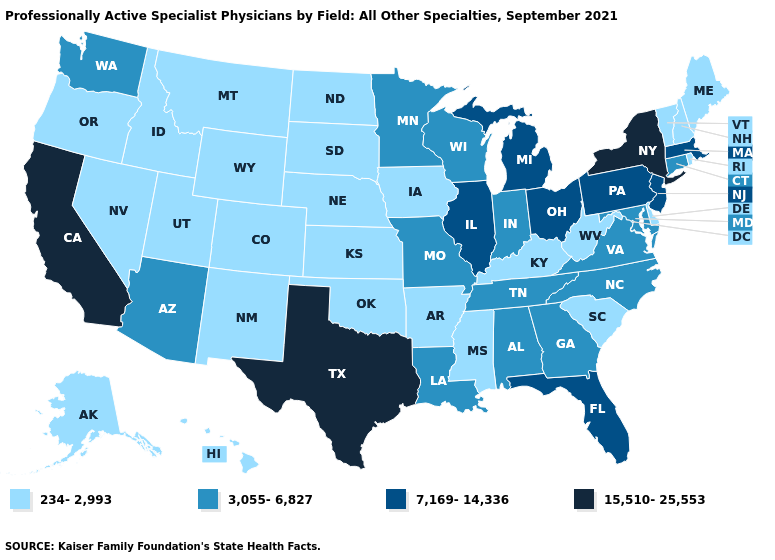What is the value of South Carolina?
Give a very brief answer. 234-2,993. What is the highest value in the USA?
Concise answer only. 15,510-25,553. What is the value of New Mexico?
Short answer required. 234-2,993. Does Montana have the lowest value in the West?
Concise answer only. Yes. What is the highest value in the South ?
Give a very brief answer. 15,510-25,553. Does Virginia have the same value as Kentucky?
Answer briefly. No. Is the legend a continuous bar?
Short answer required. No. What is the lowest value in the West?
Keep it brief. 234-2,993. Name the states that have a value in the range 3,055-6,827?
Write a very short answer. Alabama, Arizona, Connecticut, Georgia, Indiana, Louisiana, Maryland, Minnesota, Missouri, North Carolina, Tennessee, Virginia, Washington, Wisconsin. What is the value of Nebraska?
Quick response, please. 234-2,993. What is the value of Washington?
Short answer required. 3,055-6,827. Name the states that have a value in the range 7,169-14,336?
Answer briefly. Florida, Illinois, Massachusetts, Michigan, New Jersey, Ohio, Pennsylvania. Name the states that have a value in the range 234-2,993?
Be succinct. Alaska, Arkansas, Colorado, Delaware, Hawaii, Idaho, Iowa, Kansas, Kentucky, Maine, Mississippi, Montana, Nebraska, Nevada, New Hampshire, New Mexico, North Dakota, Oklahoma, Oregon, Rhode Island, South Carolina, South Dakota, Utah, Vermont, West Virginia, Wyoming. How many symbols are there in the legend?
Be succinct. 4. Among the states that border Pennsylvania , does West Virginia have the lowest value?
Short answer required. Yes. 